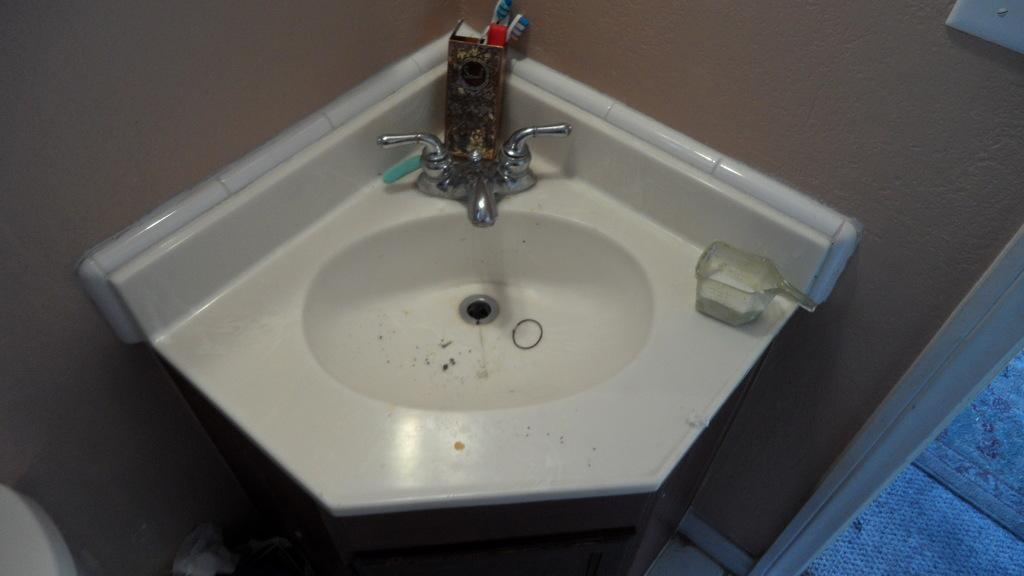What can be seen in the image for washing hands? There is a handwash sink in the image. What are the items kept near the sink for cleaning purposes? There are brushes kept in a stand near the sink. What is placed on the handwash sink? There is a mug kept on the handwash sink. Can you describe the surroundings of the sink? There is a door visible in the image. What type of plot is visible in the image? There is no plot visible in the image; it features a handwash sink, brushes, a mug, and a door. Are there any boats present in the image? There are no boats present in the image. 